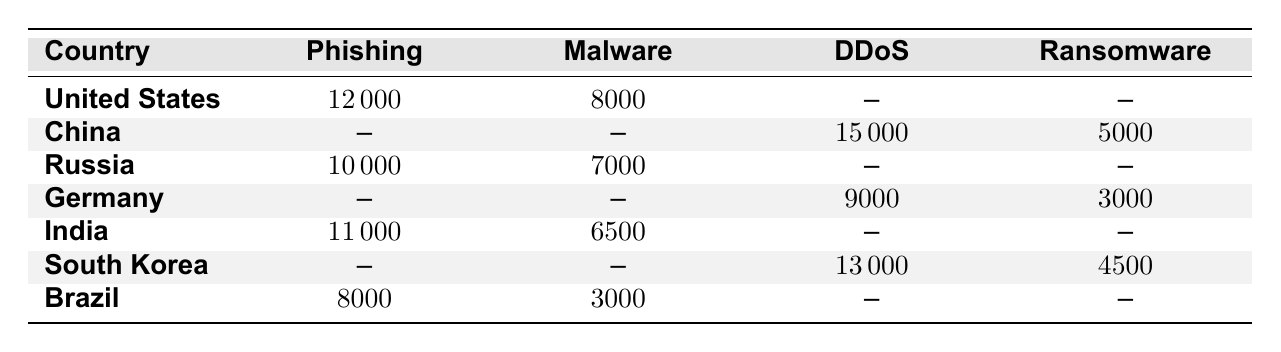What is the frequency of Phishing attacks from the United States? The table shows that the frequency of Phishing attacks from the United States is listed as 12000.
Answer: 12000 Which country has the highest frequency of DDoS attacks? According to the table, China has the highest frequency of DDoS attacks, with a frequency of 15000.
Answer: China What is the total frequency of Phishing attacks from India and Russia combined? The frequency of Phishing attacks from India is 11000 and from Russia is 10000. Adding these (11000 + 10000) gives a total of 21000.
Answer: 21000 Is there any country with a frequency of Malware attacks greater than 8000? Yes, the United States (8000), India (6500), and Russia (7000), but no country has a frequency greater than 8000 listed for Malware. Thus, the answer is no.
Answer: No What is the difference in frequency of Ransomware attacks between China and Germany? The frequency of Ransomware attacks from China is 5000, and from Germany, it is 3000. The difference is 5000 - 3000, which equals 2000.
Answer: 2000 Which country has the lowest frequency of Ransomware attacks? From the table, Germany has the lowest frequency of Ransomware attacks at 3000.
Answer: Germany What is the combined frequency of Malware attacks from Brazil and India? Brazil has a Malware frequency of 3000, and India has a frequency of 6500. The sum is (3000 + 6500) = 9500.
Answer: 9500 Are there any countries listed that have a zero frequency for DDoS attacks? The United States, Russia, India, and Brazil show no frequency listed for DDoS attacks. Thus, they all have a zero frequency for this attack vector.
Answer: Yes What is the average frequency of Phishing attacks across all listed countries? The frequencies for Phishing are 12000 (United States) + 10000 (Russia) + 11000 (India) + 8000 (Brazil), totaling 41000. There are four countries, so the average is 41000 / 4 = 10250.
Answer: 10250 Which attack vector is the most frequent in South Korea? The frequency for DDoS in South Korea is listed as 13000, which is the only vector noted for South Korea.
Answer: DDoS 